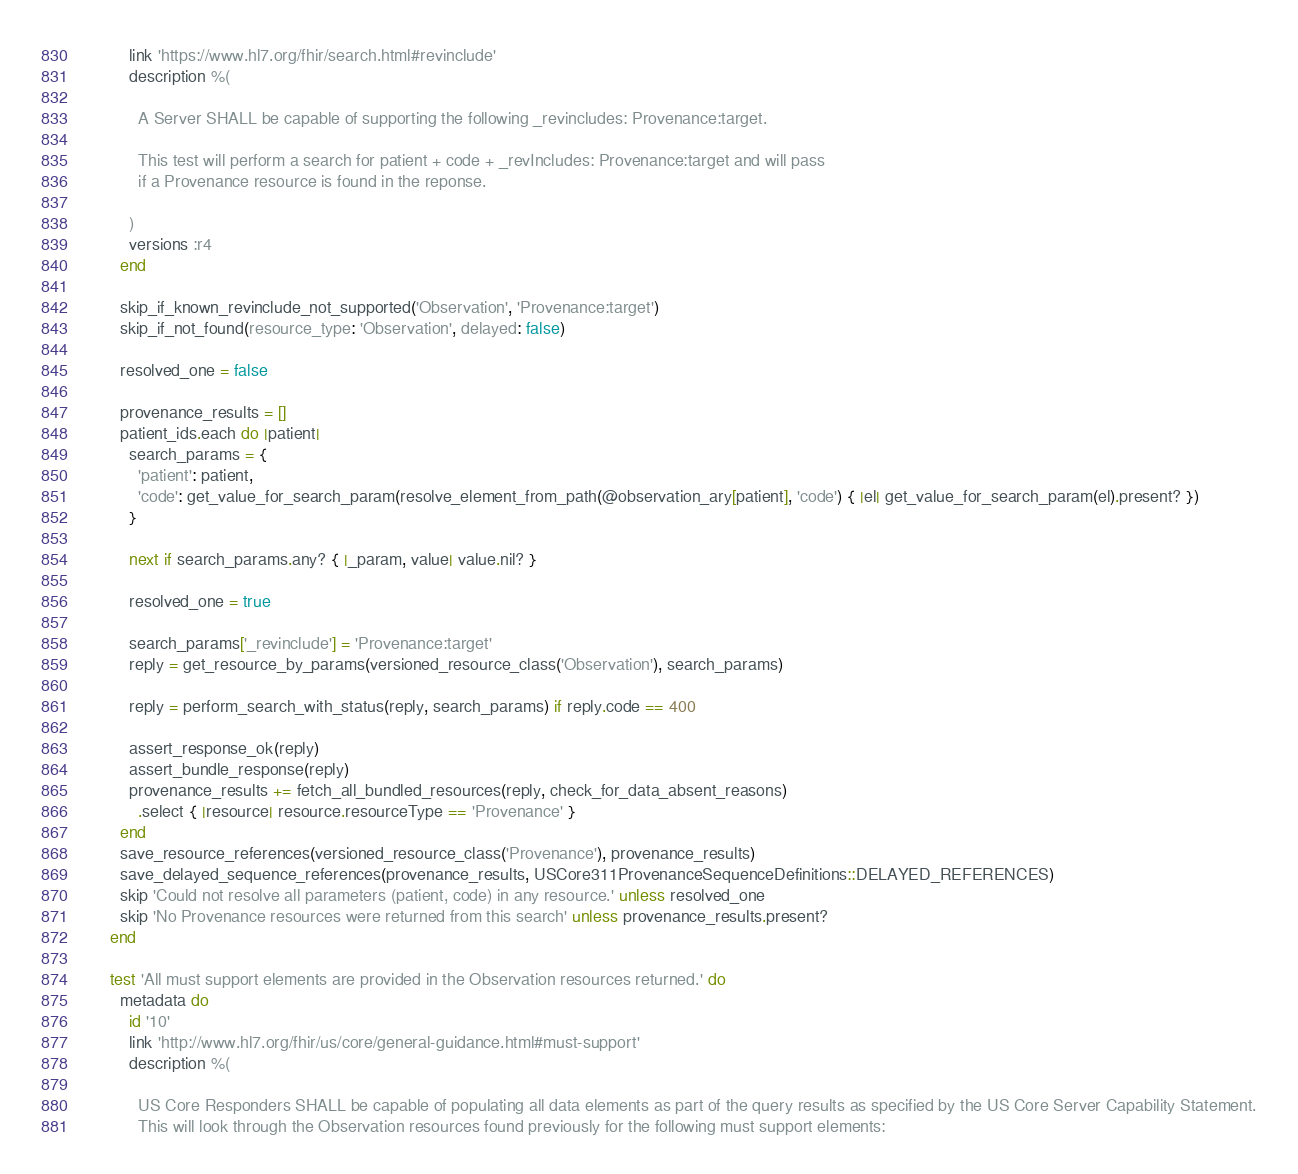Convert code to text. <code><loc_0><loc_0><loc_500><loc_500><_Ruby_>          link 'https://www.hl7.org/fhir/search.html#revinclude'
          description %(

            A Server SHALL be capable of supporting the following _revincludes: Provenance:target.

            This test will perform a search for patient + code + _revIncludes: Provenance:target and will pass
            if a Provenance resource is found in the reponse.

          )
          versions :r4
        end

        skip_if_known_revinclude_not_supported('Observation', 'Provenance:target')
        skip_if_not_found(resource_type: 'Observation', delayed: false)

        resolved_one = false

        provenance_results = []
        patient_ids.each do |patient|
          search_params = {
            'patient': patient,
            'code': get_value_for_search_param(resolve_element_from_path(@observation_ary[patient], 'code') { |el| get_value_for_search_param(el).present? })
          }

          next if search_params.any? { |_param, value| value.nil? }

          resolved_one = true

          search_params['_revinclude'] = 'Provenance:target'
          reply = get_resource_by_params(versioned_resource_class('Observation'), search_params)

          reply = perform_search_with_status(reply, search_params) if reply.code == 400

          assert_response_ok(reply)
          assert_bundle_response(reply)
          provenance_results += fetch_all_bundled_resources(reply, check_for_data_absent_reasons)
            .select { |resource| resource.resourceType == 'Provenance' }
        end
        save_resource_references(versioned_resource_class('Provenance'), provenance_results)
        save_delayed_sequence_references(provenance_results, USCore311ProvenanceSequenceDefinitions::DELAYED_REFERENCES)
        skip 'Could not resolve all parameters (patient, code) in any resource.' unless resolved_one
        skip 'No Provenance resources were returned from this search' unless provenance_results.present?
      end

      test 'All must support elements are provided in the Observation resources returned.' do
        metadata do
          id '10'
          link 'http://www.hl7.org/fhir/us/core/general-guidance.html#must-support'
          description %(

            US Core Responders SHALL be capable of populating all data elements as part of the query results as specified by the US Core Server Capability Statement.
            This will look through the Observation resources found previously for the following must support elements:
</code> 